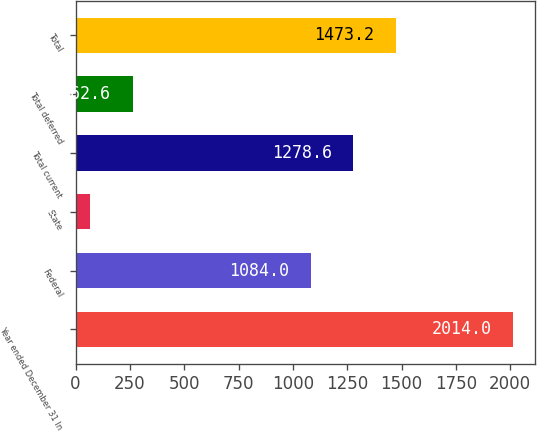Convert chart to OTSL. <chart><loc_0><loc_0><loc_500><loc_500><bar_chart><fcel>Year ended December 31 In<fcel>Federal<fcel>State<fcel>Total current<fcel>Total deferred<fcel>Total<nl><fcel>2014<fcel>1084<fcel>68<fcel>1278.6<fcel>262.6<fcel>1473.2<nl></chart> 